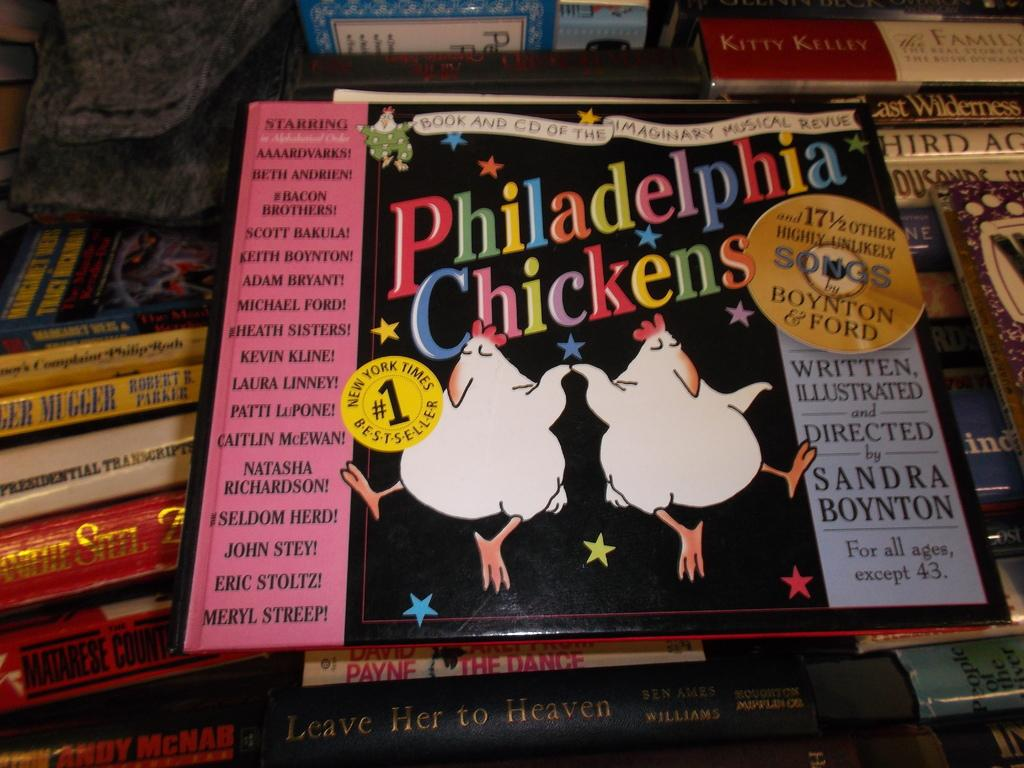<image>
Create a compact narrative representing the image presented. A stack of books with Philadelphia Chickens on top. 